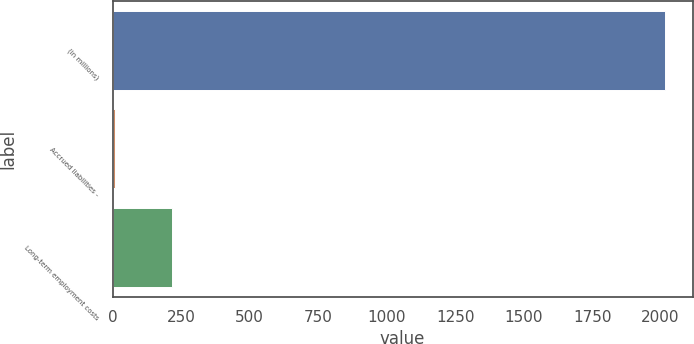Convert chart to OTSL. <chart><loc_0><loc_0><loc_500><loc_500><bar_chart><fcel>(in millions)<fcel>Accrued liabilities -<fcel>Long-term employment costs<nl><fcel>2016<fcel>10<fcel>217<nl></chart> 